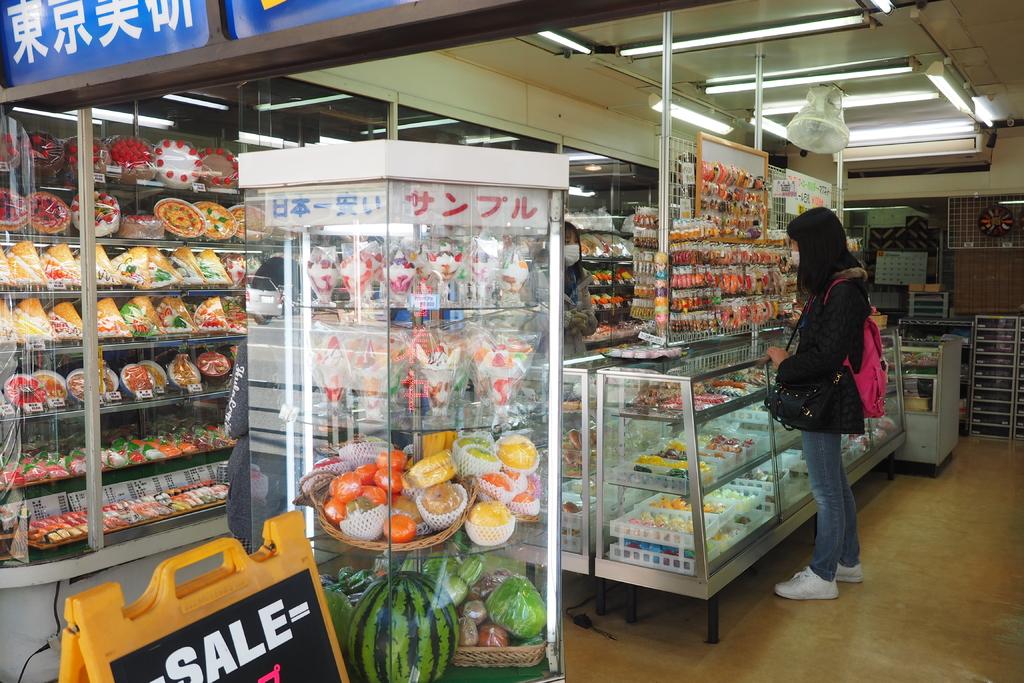Is there a sale sign?
Your answer should be very brief. Yes. 